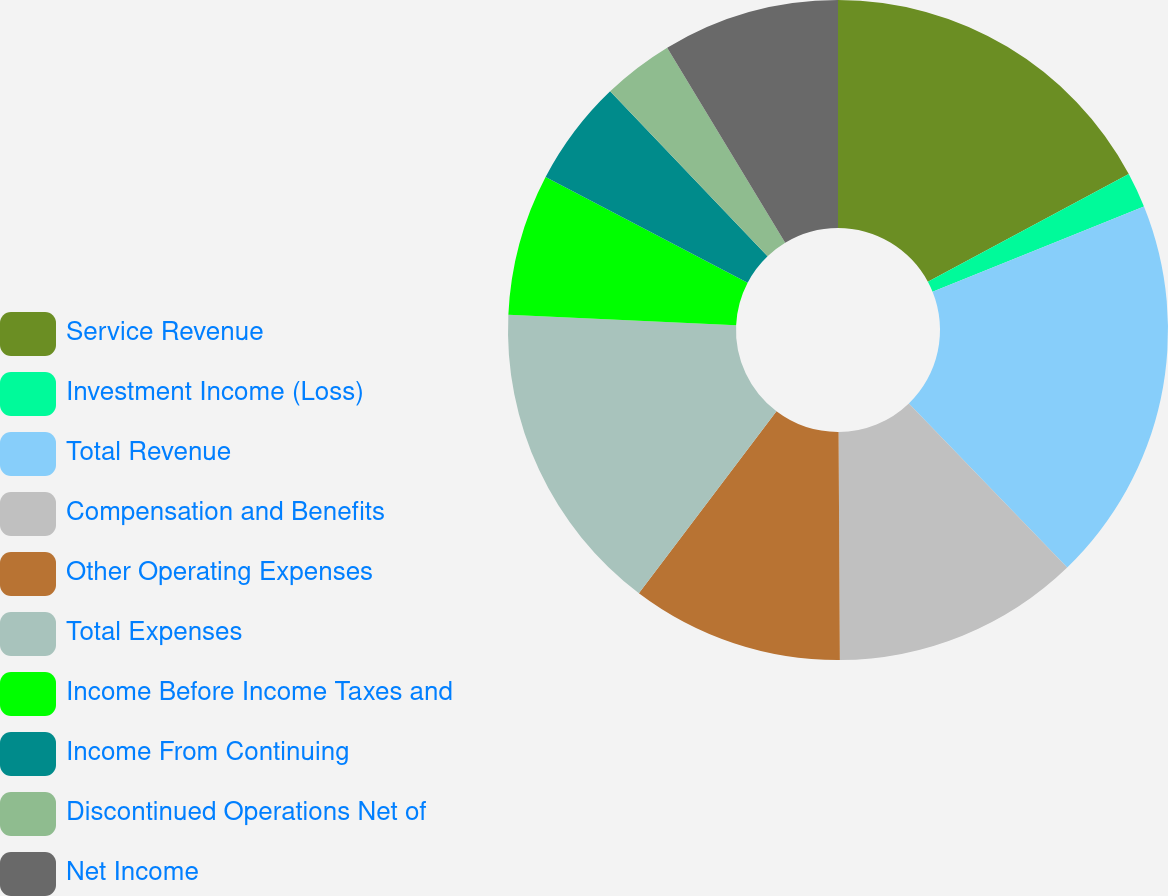Convert chart. <chart><loc_0><loc_0><loc_500><loc_500><pie_chart><fcel>Service Revenue<fcel>Investment Income (Loss)<fcel>Total Revenue<fcel>Compensation and Benefits<fcel>Other Operating Expenses<fcel>Total Expenses<fcel>Income Before Income Taxes and<fcel>Income From Continuing<fcel>Discontinued Operations Net of<fcel>Net Income<nl><fcel>17.16%<fcel>1.73%<fcel>18.89%<fcel>12.13%<fcel>10.4%<fcel>15.43%<fcel>6.93%<fcel>5.2%<fcel>3.47%<fcel>8.66%<nl></chart> 